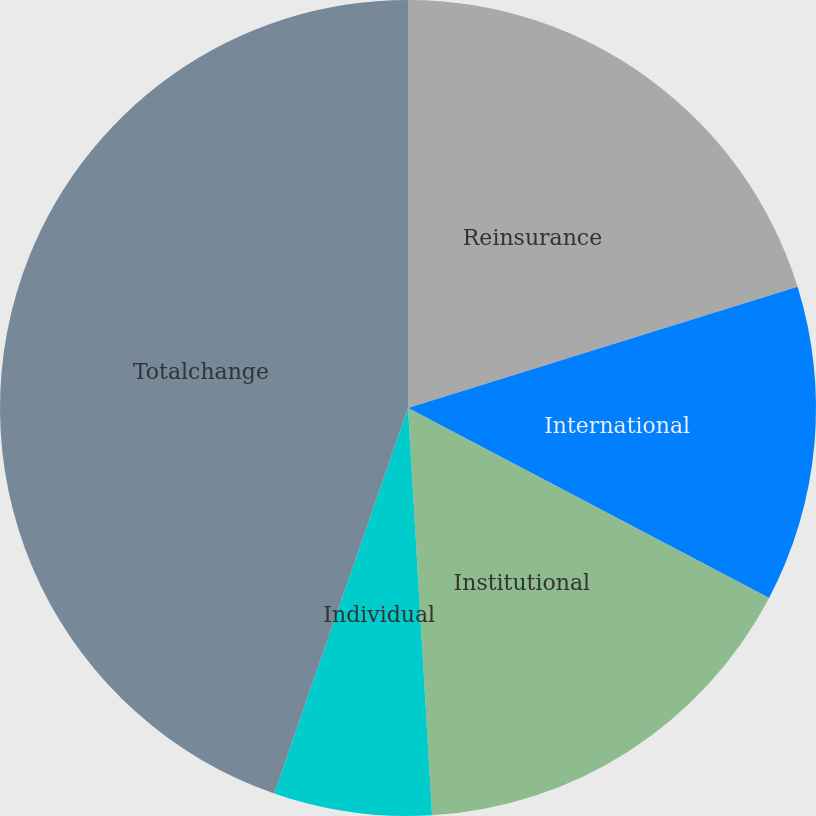<chart> <loc_0><loc_0><loc_500><loc_500><pie_chart><fcel>Reinsurance<fcel>International<fcel>Institutional<fcel>Individual<fcel>Totalchange<nl><fcel>20.2%<fcel>12.51%<fcel>16.35%<fcel>6.26%<fcel>44.68%<nl></chart> 